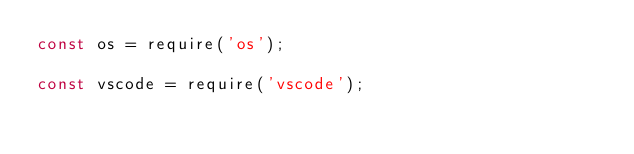Convert code to text. <code><loc_0><loc_0><loc_500><loc_500><_JavaScript_>const os = require('os');

const vscode = require('vscode');</code> 